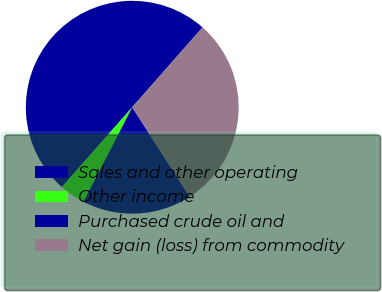Convert chart. <chart><loc_0><loc_0><loc_500><loc_500><pie_chart><fcel>Sales and other operating<fcel>Other income<fcel>Purchased crude oil and<fcel>Net gain (loss) from commodity<nl><fcel>50.0%<fcel>3.91%<fcel>16.67%<fcel>29.43%<nl></chart> 